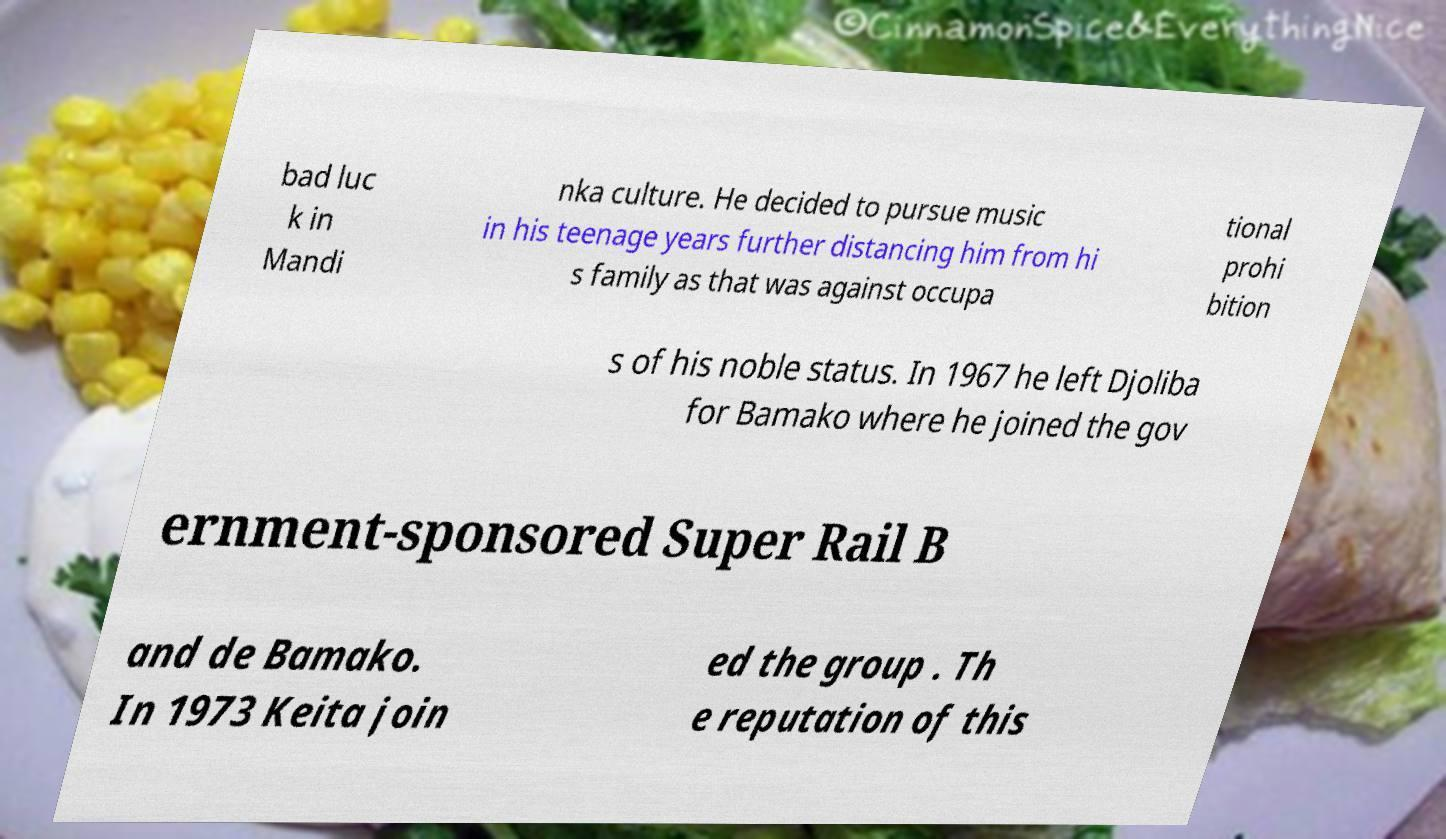Can you read and provide the text displayed in the image?This photo seems to have some interesting text. Can you extract and type it out for me? bad luc k in Mandi nka culture. He decided to pursue music in his teenage years further distancing him from hi s family as that was against occupa tional prohi bition s of his noble status. In 1967 he left Djoliba for Bamako where he joined the gov ernment-sponsored Super Rail B and de Bamako. In 1973 Keita join ed the group . Th e reputation of this 